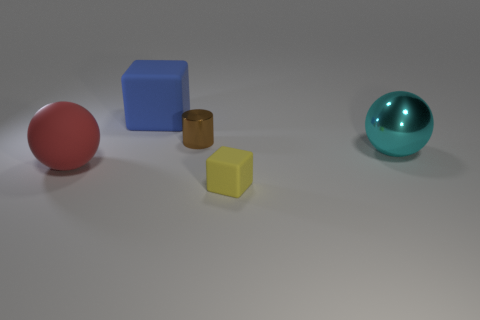Add 3 tiny brown cylinders. How many objects exist? 8 Subtract all cubes. How many objects are left? 3 Subtract 0 green balls. How many objects are left? 5 Subtract all large purple shiny blocks. Subtract all cyan spheres. How many objects are left? 4 Add 4 large blue matte cubes. How many large blue matte cubes are left? 5 Add 1 big cyan metallic objects. How many big cyan metallic objects exist? 2 